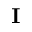Convert formula to latex. <formula><loc_0><loc_0><loc_500><loc_500>I</formula> 